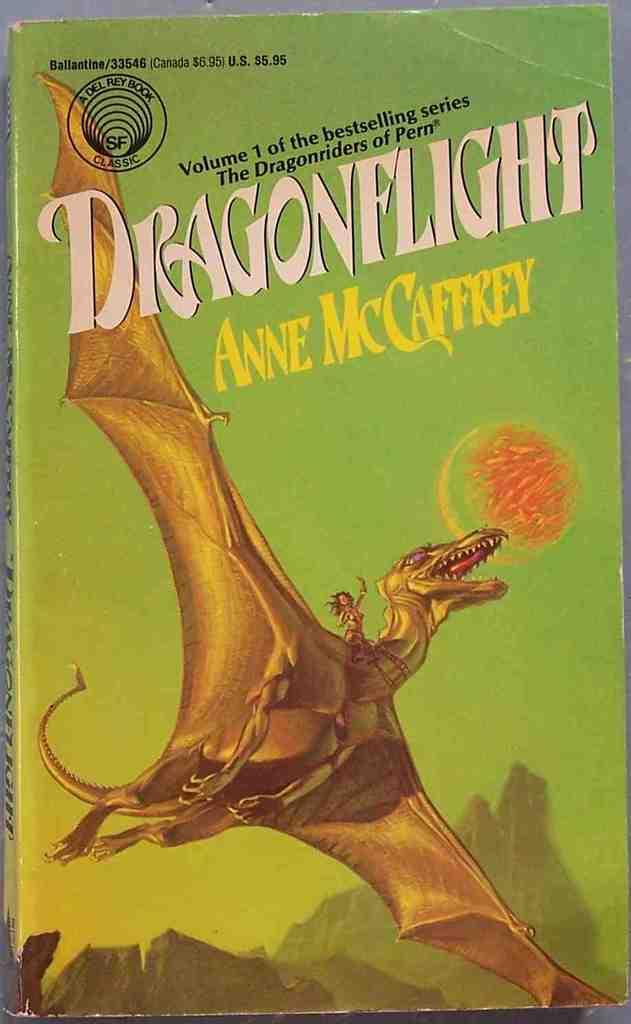What object is present in the image that is related to literature? There is a book in the image. What is depicted on the book? The book has a painting of a dragon. Are there any words or text on the book? Yes, there is writing on the book. What type of farm animals can be seen grazing on the land in the image? There is no farm or land present in the image; it features a book with a dragon painting. How many stamps are visible on the book in the image? There are no stamps visible on the book in the image. 